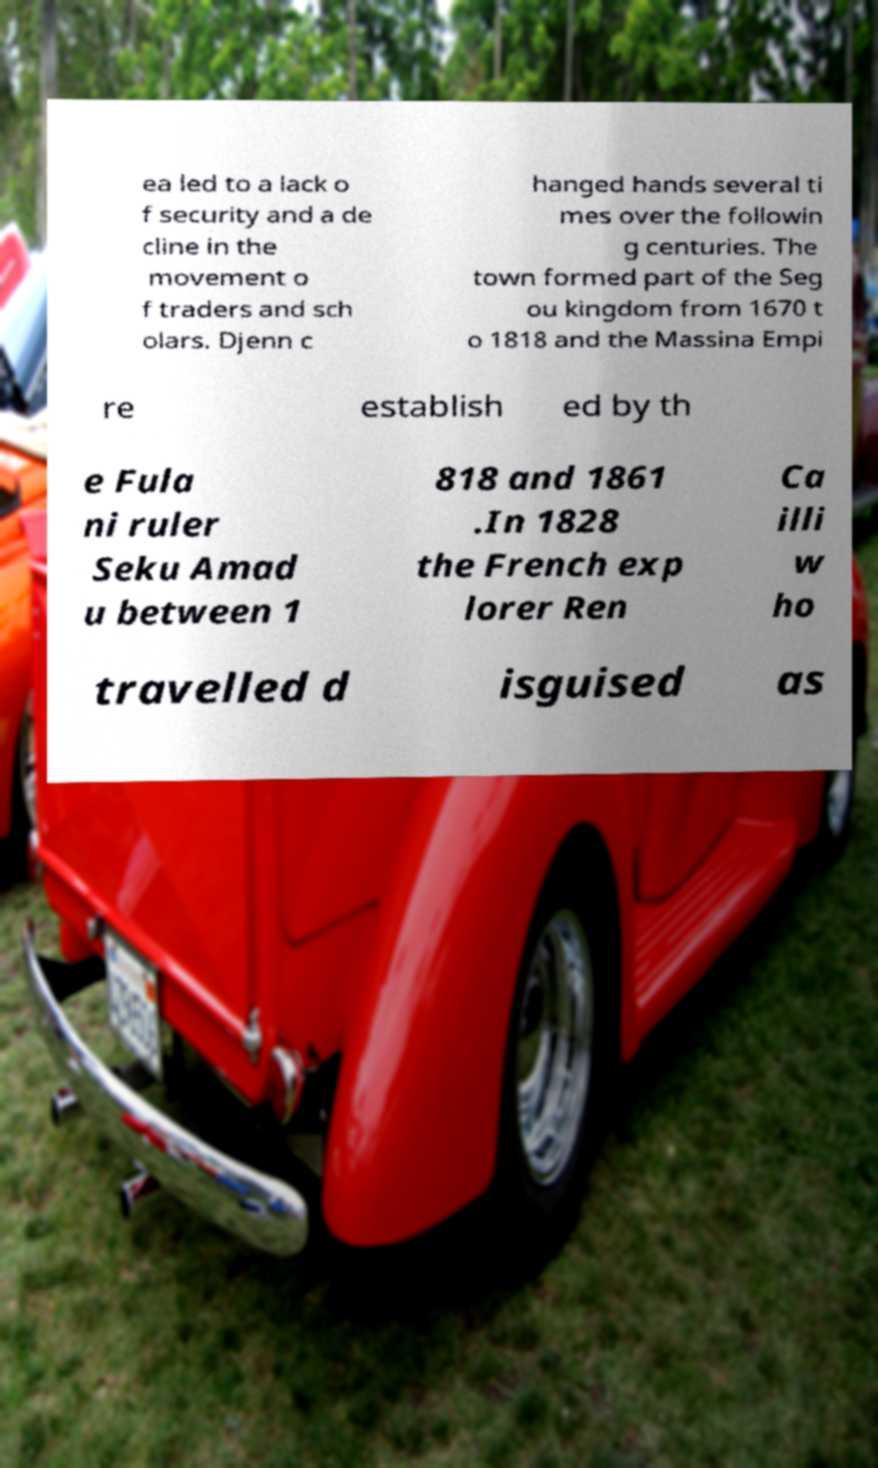For documentation purposes, I need the text within this image transcribed. Could you provide that? ea led to a lack o f security and a de cline in the movement o f traders and sch olars. Djenn c hanged hands several ti mes over the followin g centuries. The town formed part of the Seg ou kingdom from 1670 t o 1818 and the Massina Empi re establish ed by th e Fula ni ruler Seku Amad u between 1 818 and 1861 .In 1828 the French exp lorer Ren Ca illi w ho travelled d isguised as 